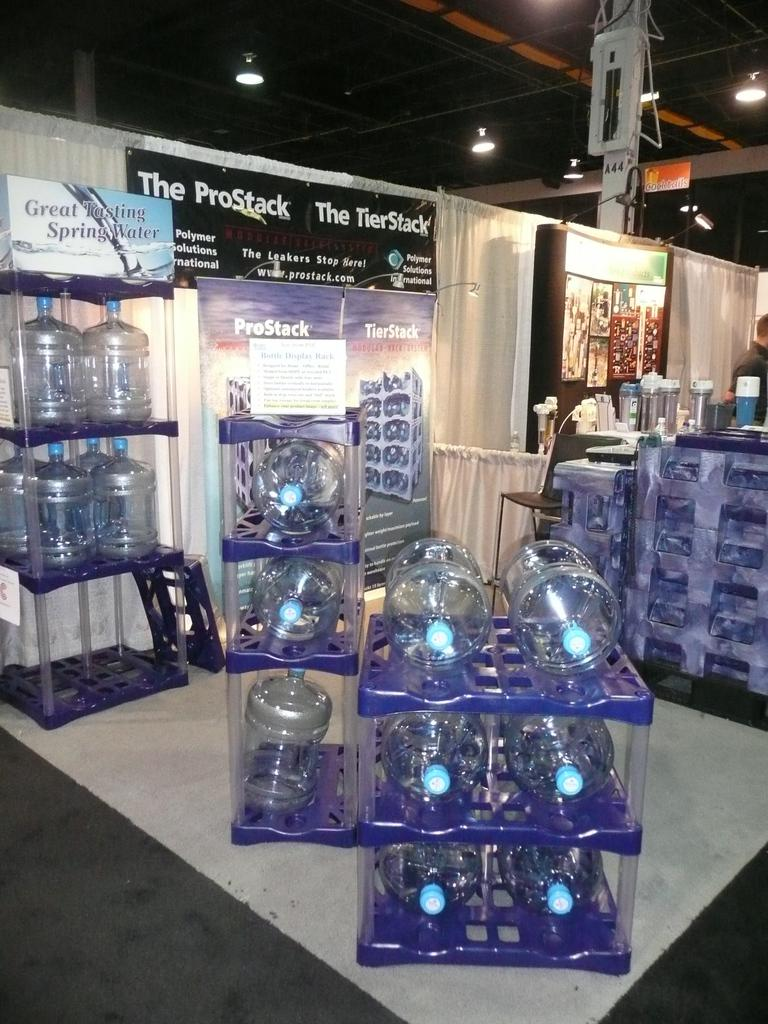What is the primary surface visible in the image? There is a floor in the image. What objects can be seen on the shelf in the image? There are water cans on a shelf in the image. What month is depicted in the image? There is no specific month depicted in the image; it only shows a floor and water cans on a shelf. Can you see a laborer working in the image? There is no laborer present in the image. 